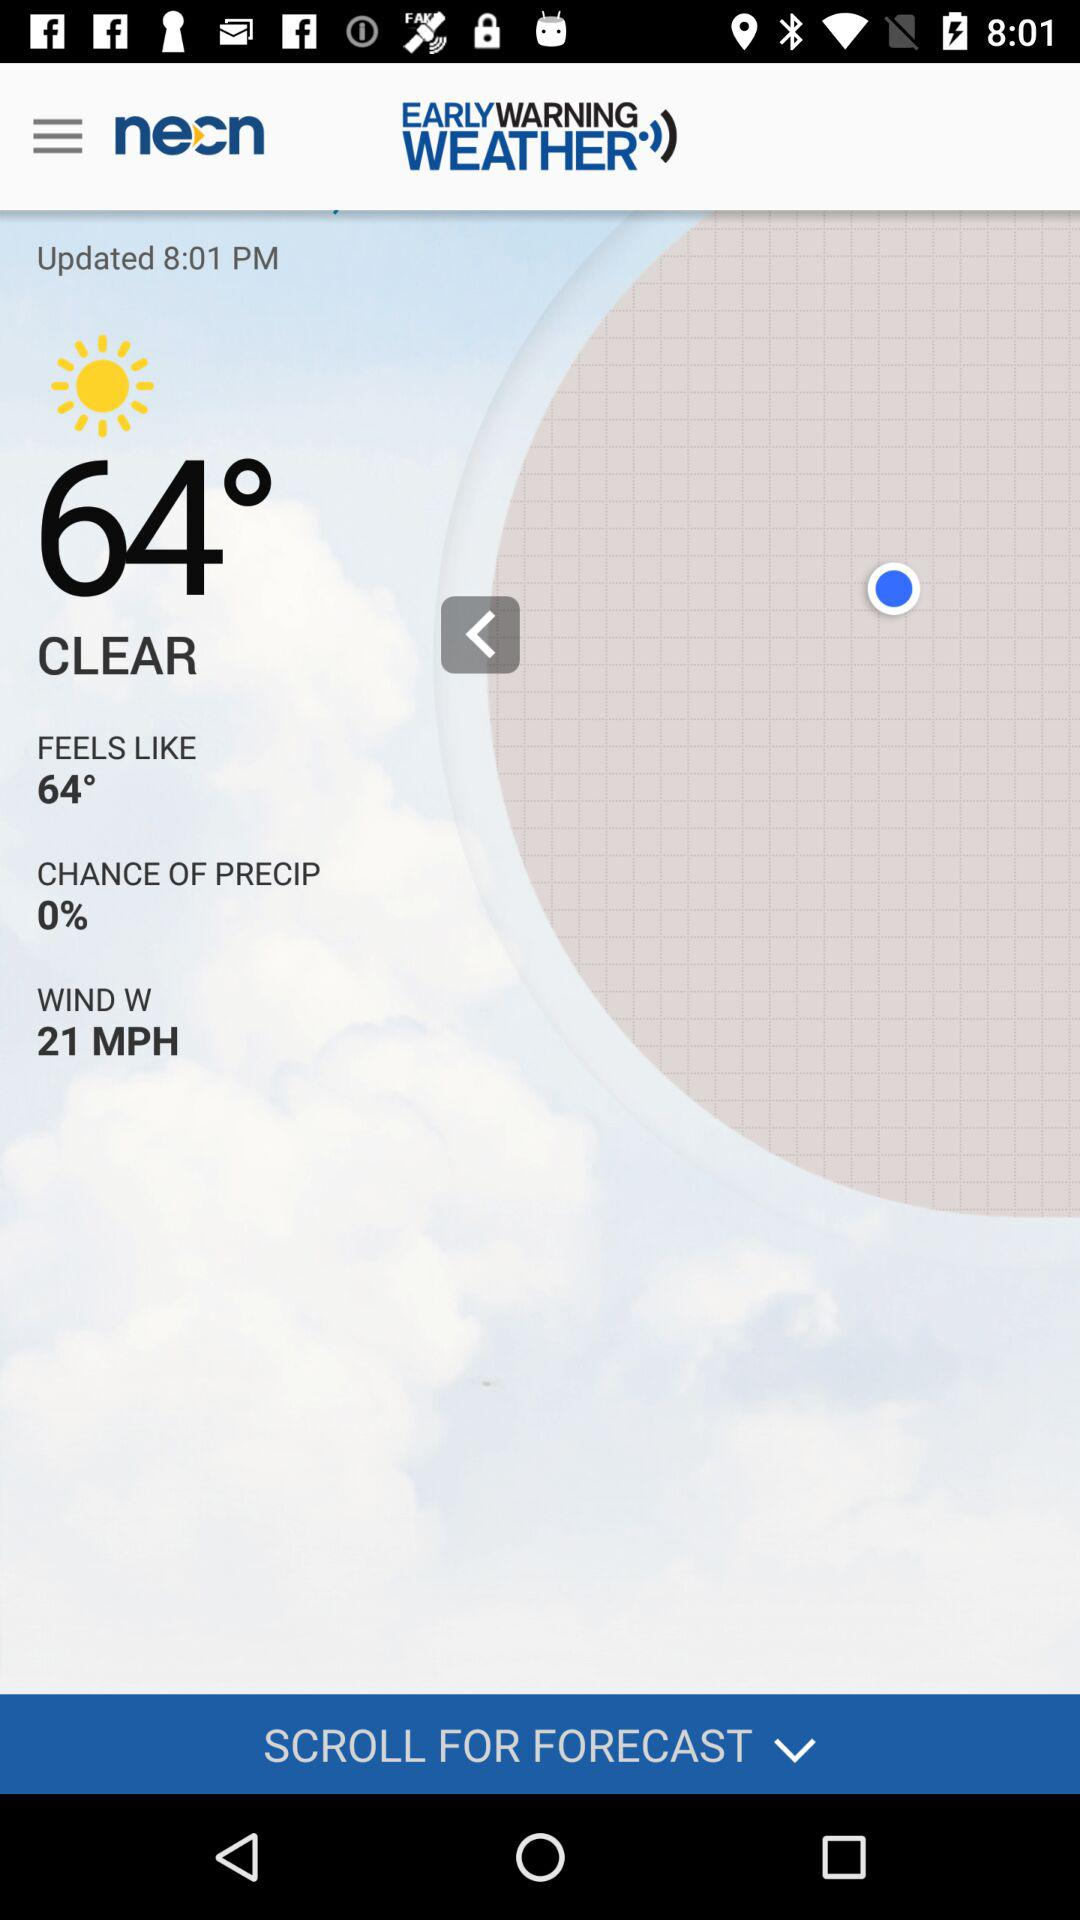How's the weather? The weather is 64°. 